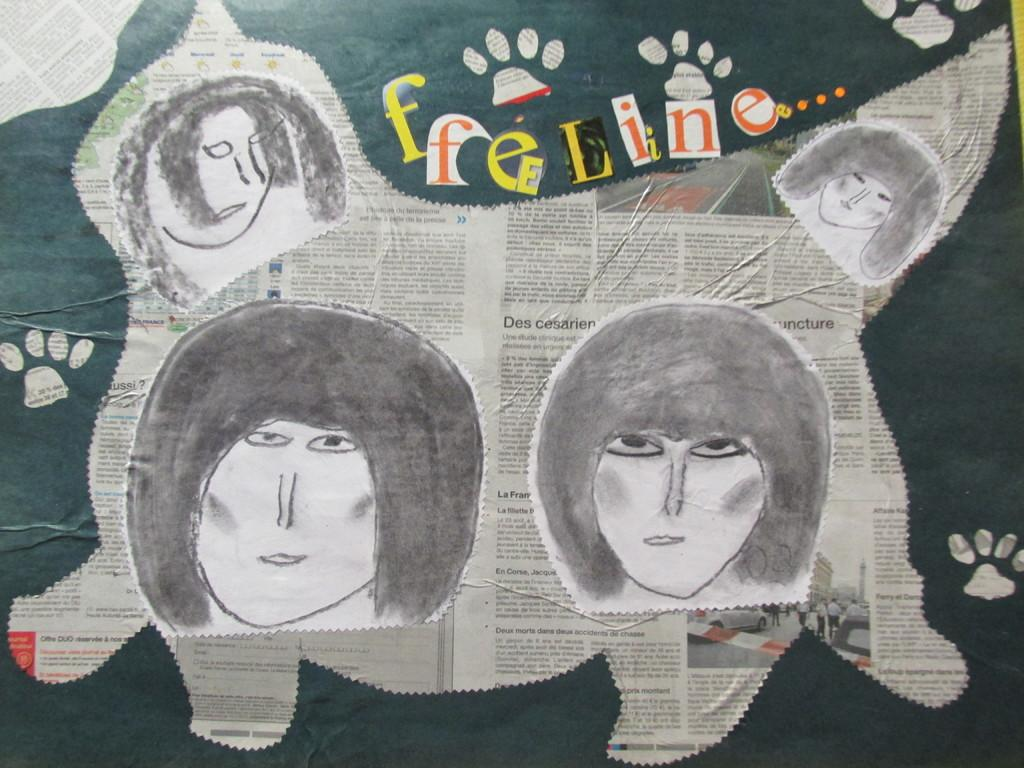What is the main object in the image? There is a notice board in the image. What is attached to the notice board? The notice board has a paper cut in the shape of an animal. What can be seen on the paper cut? There are face drawings on the paper cut. How many rabbits are playing in the stream near the notice board? There are no rabbits or stream present in the image; it only features a notice board with a paper cut. 